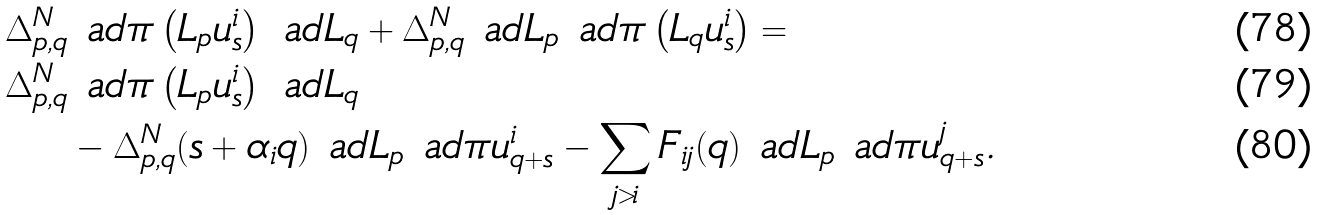<formula> <loc_0><loc_0><loc_500><loc_500>\Delta ^ { N } _ { p , q } & \ a d \pi \left ( L _ { p } u ^ { i } _ { s } \right ) \ a d L _ { q } + \Delta ^ { N } _ { p , q } \ a d L _ { p } \ a d \pi \left ( L _ { q } u ^ { i } _ { s } \right ) = \\ \Delta ^ { N } _ { p , q } & \ a d \pi \left ( L _ { p } u ^ { i } _ { s } \right ) \ a d L _ { q } \\ & - \Delta ^ { N } _ { p , q } ( s + \alpha _ { i } q ) \ a d L _ { p } \ a d \pi u ^ { i } _ { q + s } - \sum _ { j > i } F _ { i j } ( q ) \ a d L _ { p } \ a d \pi u ^ { j } _ { q + s } .</formula> 